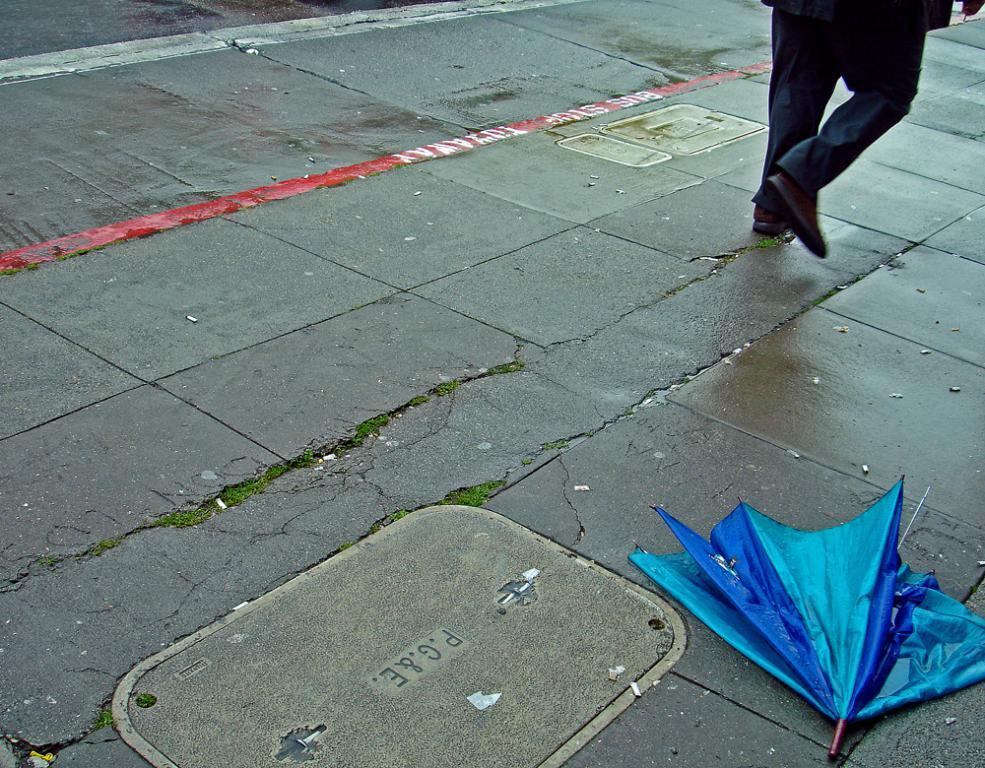Can you describe this image briefly? In this picture there is an umbrella on the floor in the bottom right side of the image and there is a man at the top side of the image. 